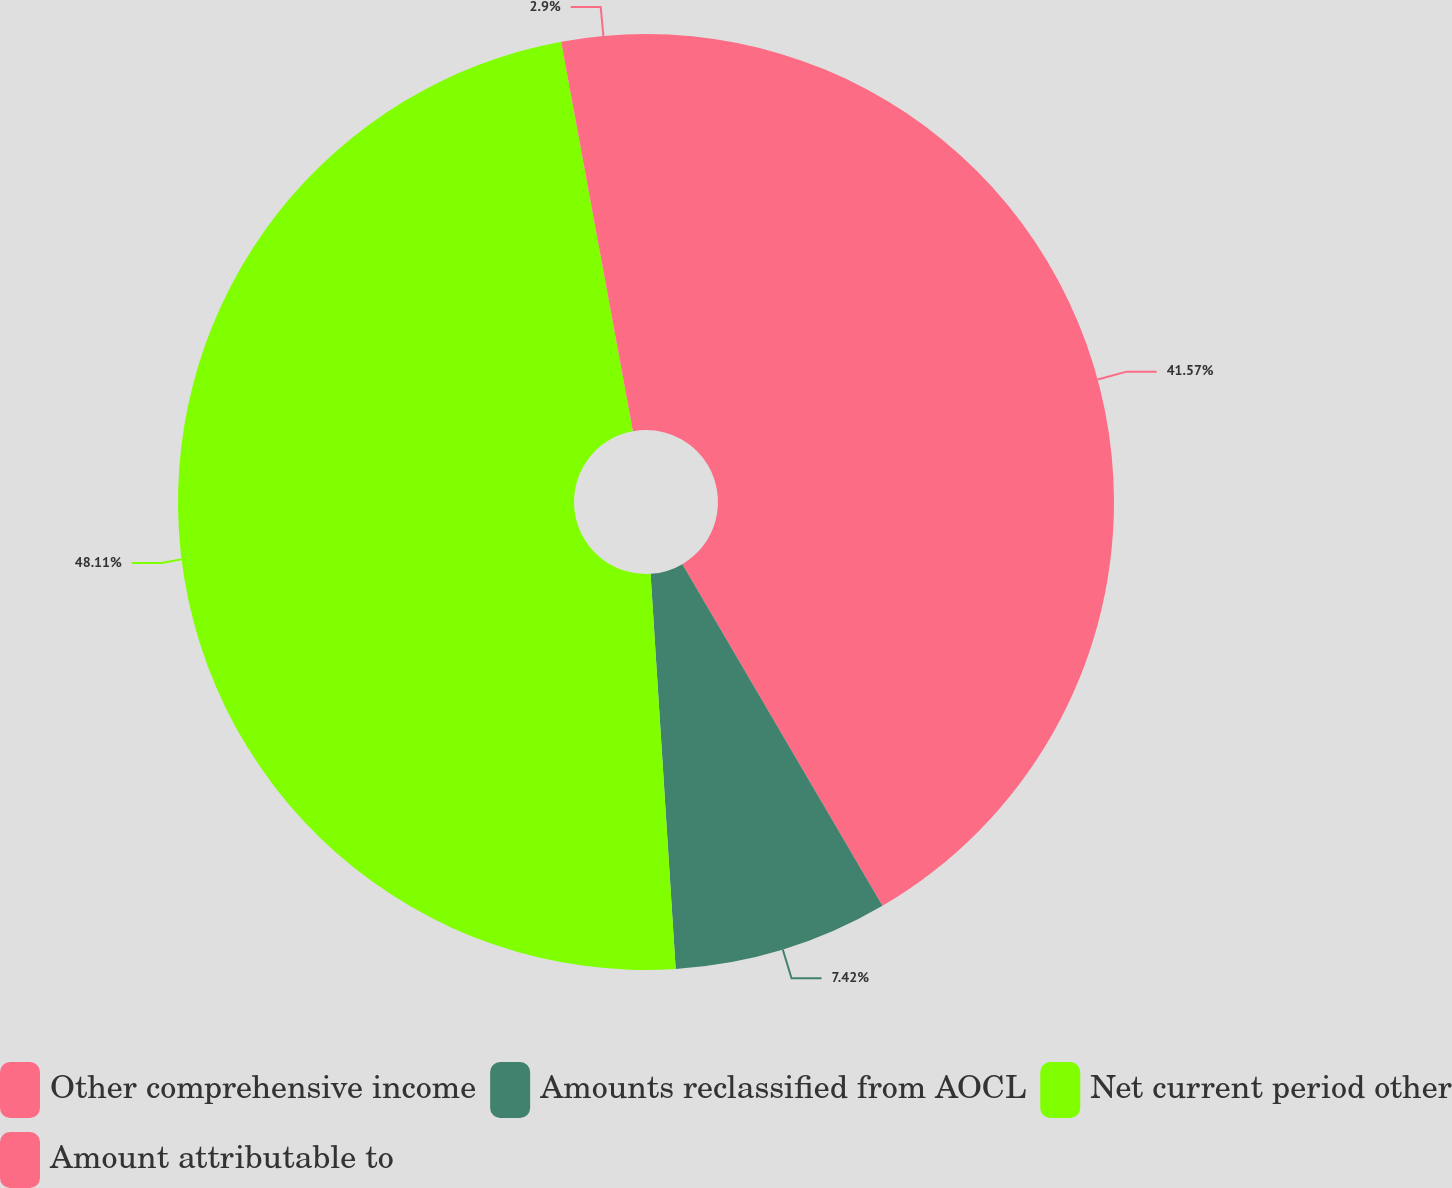Convert chart. <chart><loc_0><loc_0><loc_500><loc_500><pie_chart><fcel>Other comprehensive income<fcel>Amounts reclassified from AOCL<fcel>Net current period other<fcel>Amount attributable to<nl><fcel>41.57%<fcel>7.42%<fcel>48.11%<fcel>2.9%<nl></chart> 